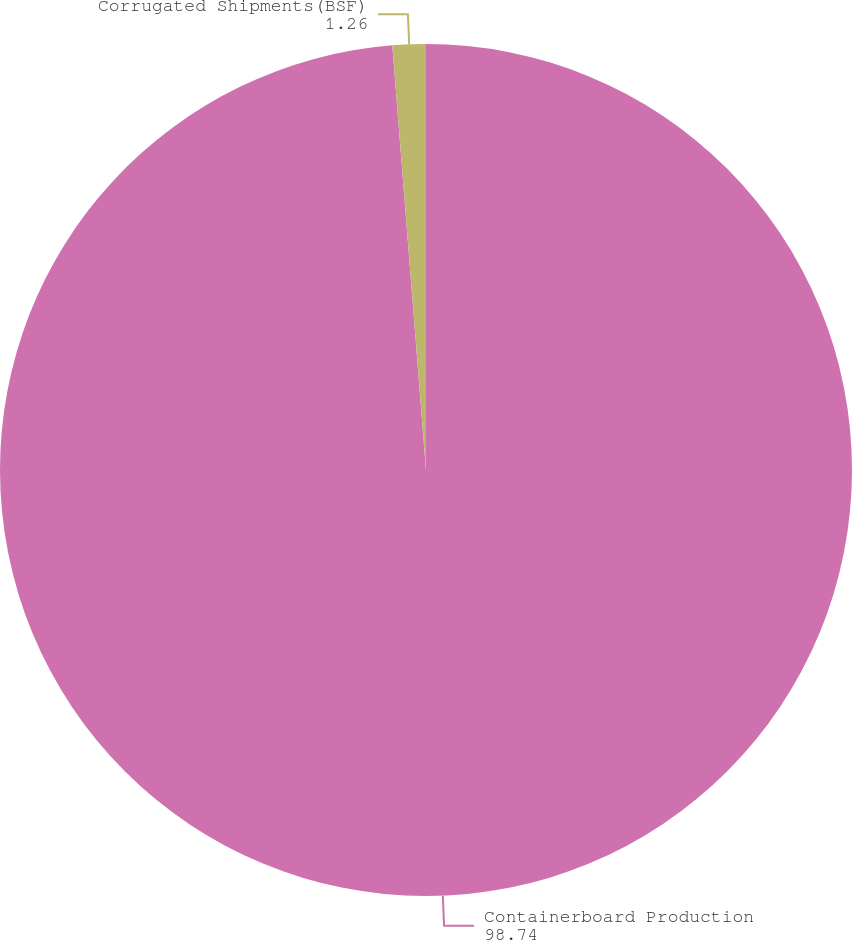Convert chart. <chart><loc_0><loc_0><loc_500><loc_500><pie_chart><fcel>Containerboard Production<fcel>Corrugated Shipments(BSF)<nl><fcel>98.74%<fcel>1.26%<nl></chart> 